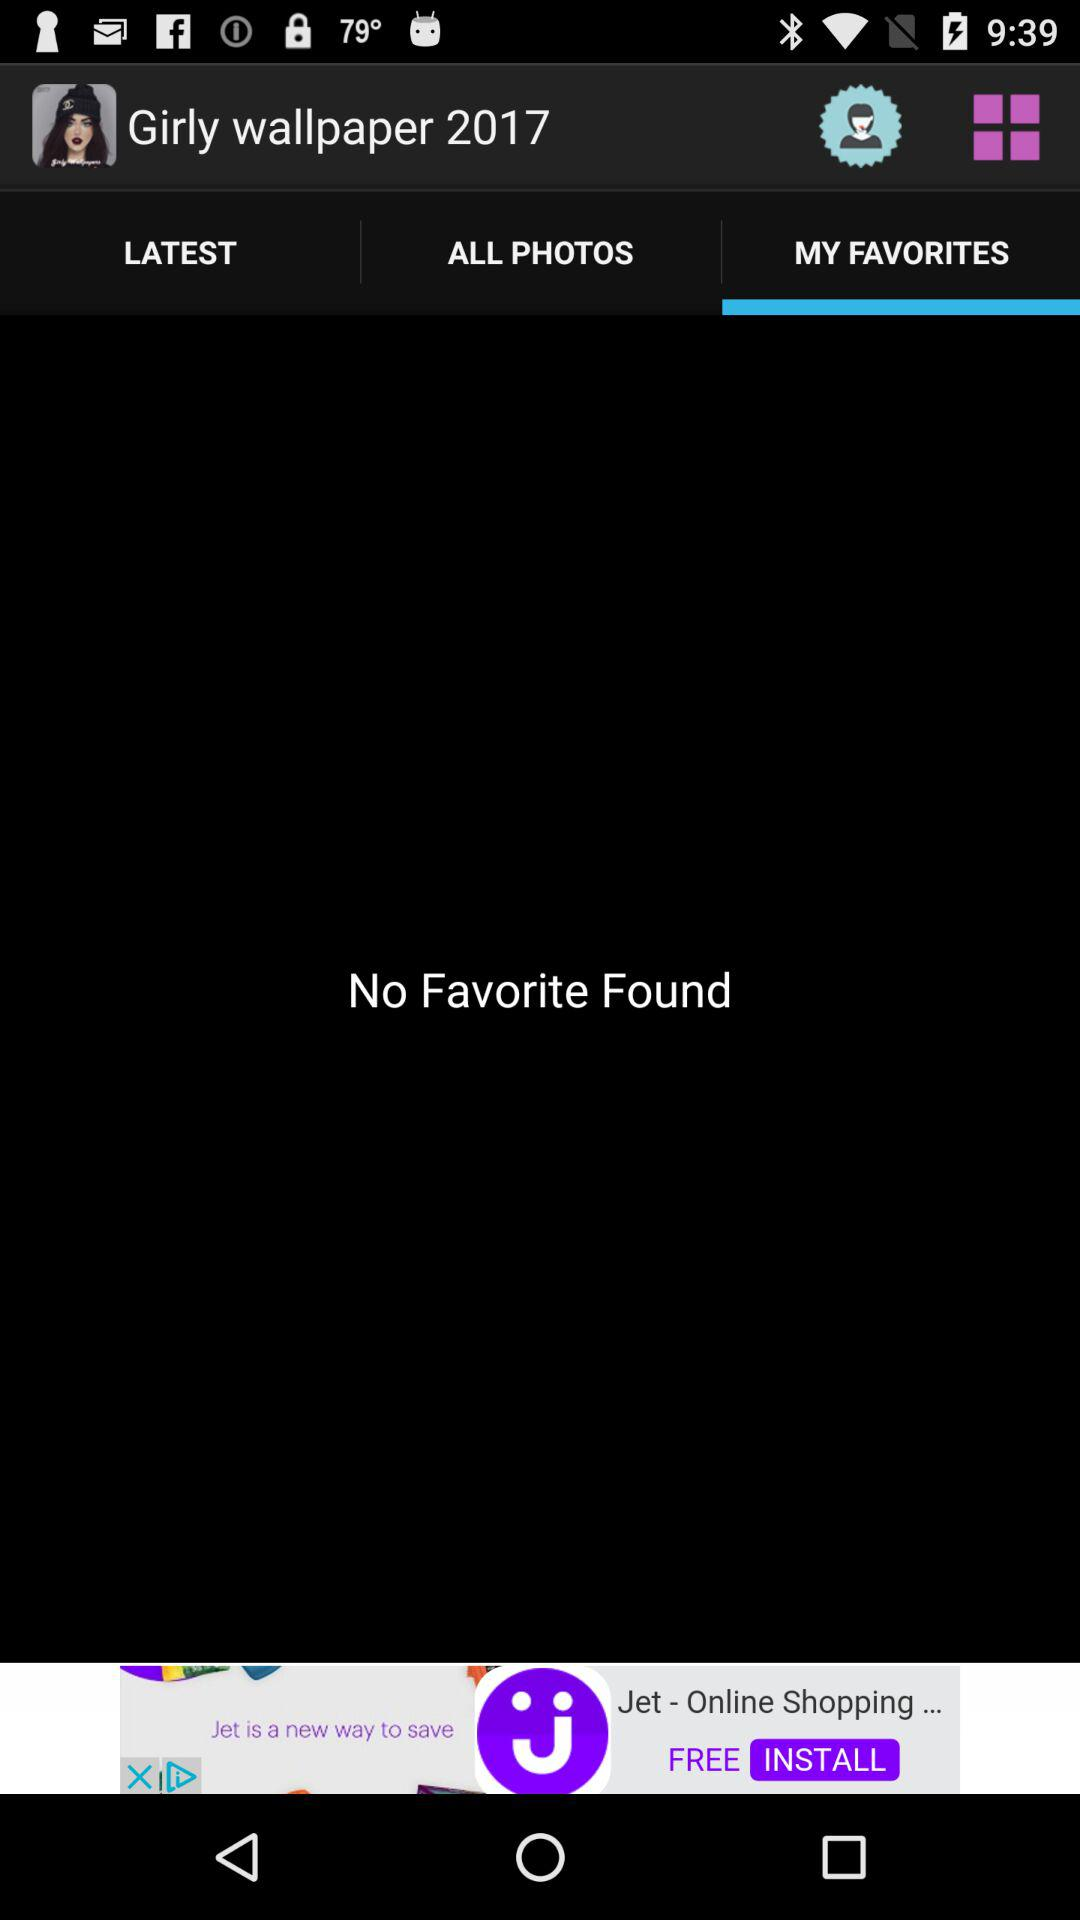Which option is selected in "Girly wallpaper 2017"? The selected option is "MY FAVORITES". 